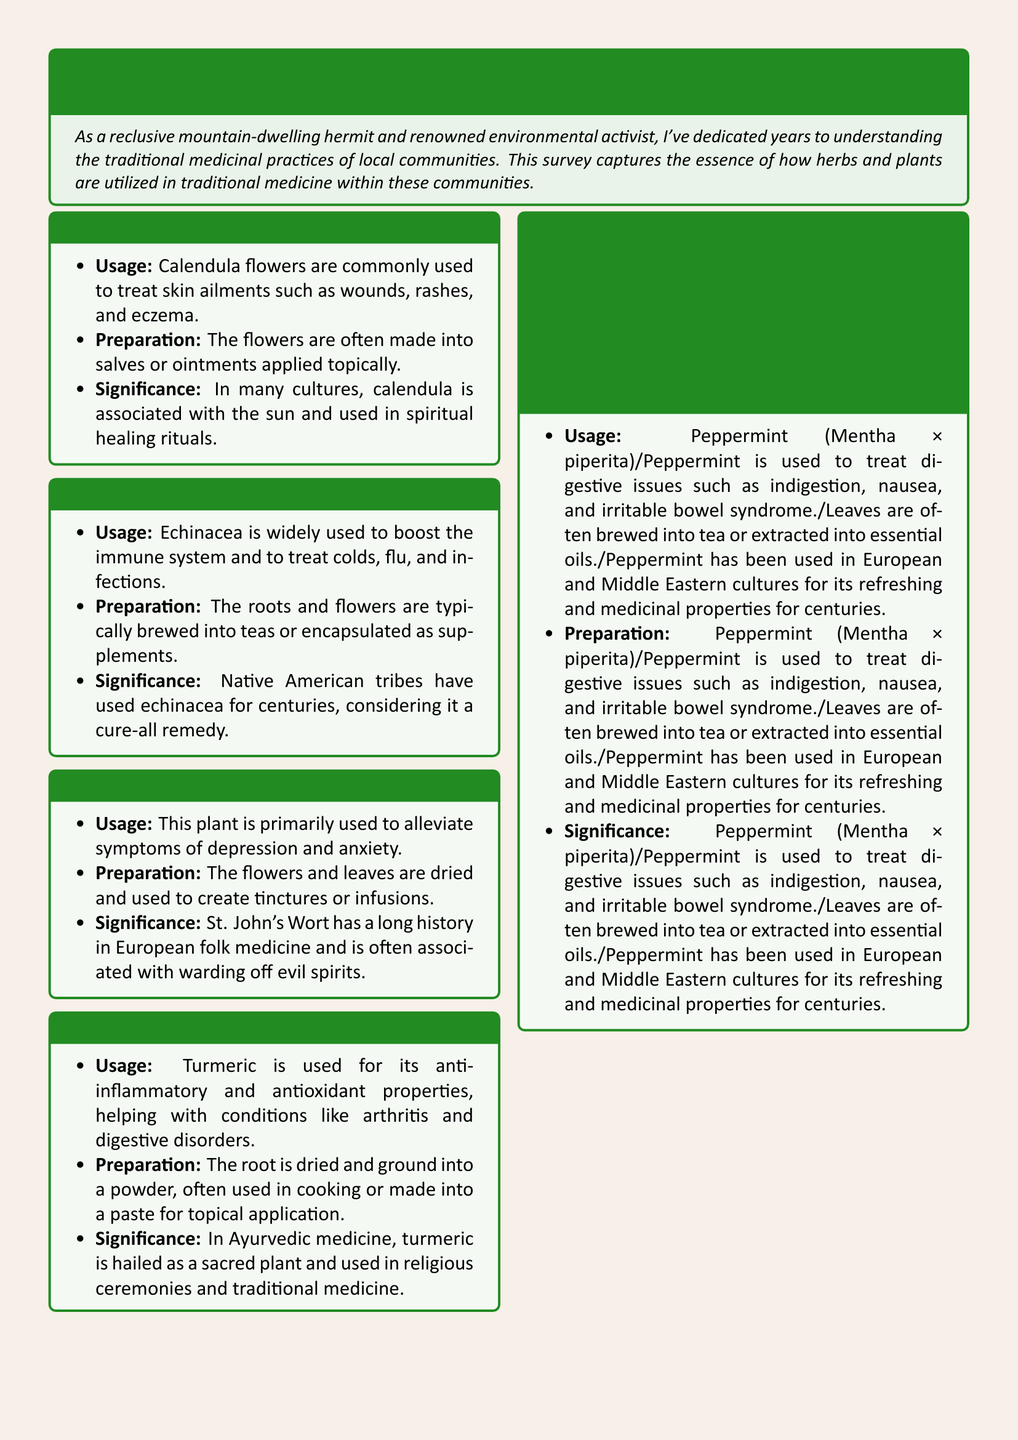What plant is used to treat skin ailments? The document states that Calendula flowers are used to treat skin ailments such as wounds, rashes, and eczema.
Answer: Calendula What preparation method is mentioned for Echinacea? Echinacea roots and flowers are typically brewed into teas or encapsulated as supplements according to the document.
Answer: Brewed into teas or encapsulated as supplements What plant is associated with alleviating depression and anxiety? St. John's Wort is primarily used to alleviate symptoms of depression and anxiety, as stated in the document.
Answer: St. John's Wort What cultural significance is noted for turmeric? Turmeric is hailed as a sacred plant in Ayurvedic medicine and is used in religious ceremonies and traditional medicine.
Answer: Sacred plant Which plant is used for digestive issues? The document refers to Peppermint being used to treat digestive issues such as indigestion, nausea, and irritable bowel syndrome.
Answer: Peppermint How many plants are mentioned in the survey findings? The document lists five plants utilized in traditional medicine practices as a part of the local community survey findings.
Answer: Five What is the primary purpose of the document? The primary purpose is to capture how herbs and plants are utilized in traditional medicine within local communities.
Answer: Capture usage What does the conclusion emphasize about the plant usage? The conclusion highlights the unique methods of preparation and cultural significance of each plant in traditional medicine.
Answer: Unique methods and significance What historical aspect is mentioned regarding Echinacea? The document mentions that Native American tribes have used Echinacea for centuries.
Answer: Centuries What is the color theme of the document? The document uses a light brown background combined with forest green elements for a natural feel.
Answer: Light brown and forest green 